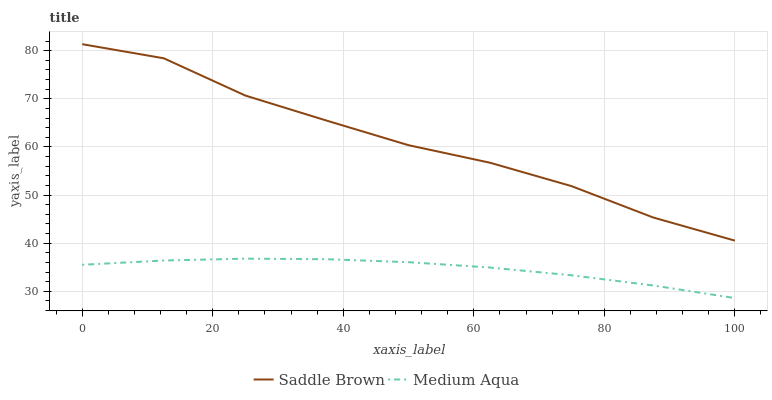Does Medium Aqua have the minimum area under the curve?
Answer yes or no. Yes. Does Saddle Brown have the maximum area under the curve?
Answer yes or no. Yes. Does Saddle Brown have the minimum area under the curve?
Answer yes or no. No. Is Medium Aqua the smoothest?
Answer yes or no. Yes. Is Saddle Brown the roughest?
Answer yes or no. Yes. Is Saddle Brown the smoothest?
Answer yes or no. No. Does Medium Aqua have the lowest value?
Answer yes or no. Yes. Does Saddle Brown have the lowest value?
Answer yes or no. No. Does Saddle Brown have the highest value?
Answer yes or no. Yes. Is Medium Aqua less than Saddle Brown?
Answer yes or no. Yes. Is Saddle Brown greater than Medium Aqua?
Answer yes or no. Yes. Does Medium Aqua intersect Saddle Brown?
Answer yes or no. No. 